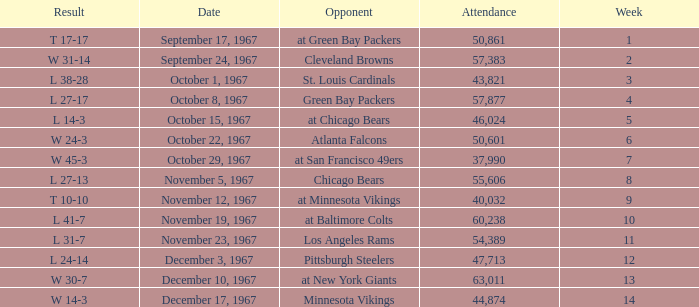How many weeks have a Result of t 10-10? 1.0. 